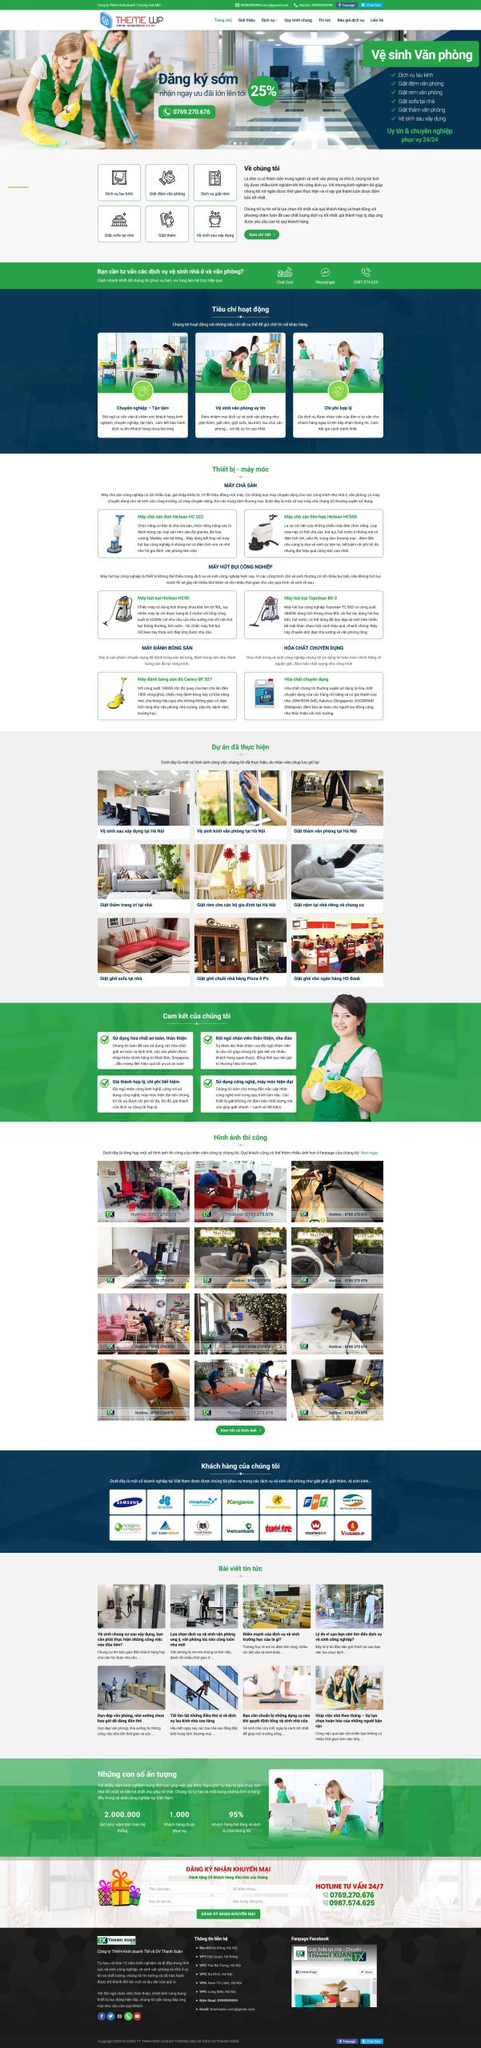Liệt kê 5 ngành nghề, lĩnh vực phù hợp với website này, phân cách các màu sắc bằng dấu phẩy. Chỉ trả về kết quả, phân cách bằng dấy phẩy
 Vệ sinh văn phòng, Vệ sinh nhà ở, Vệ sinh công nghiệp, Vệ sinh trường học, Vệ sinh bệnh viện 